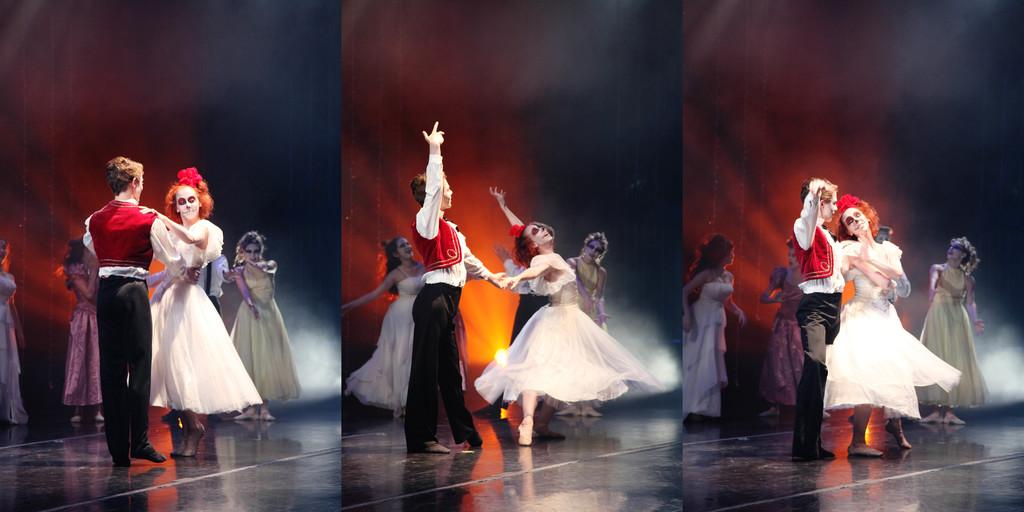What type of visual composition is present in the image? The image contains a collage of pictures. What are the subjects of the pictures in the collage? The pictures depict persons performing. Where is the performance taking place? The performance is taking place on a dais. Can you tell me how many girls are performing on the dais in the image? There is no mention of a girl or girls performing in the image; the pictures depict persons performing, but their gender is not specified. 